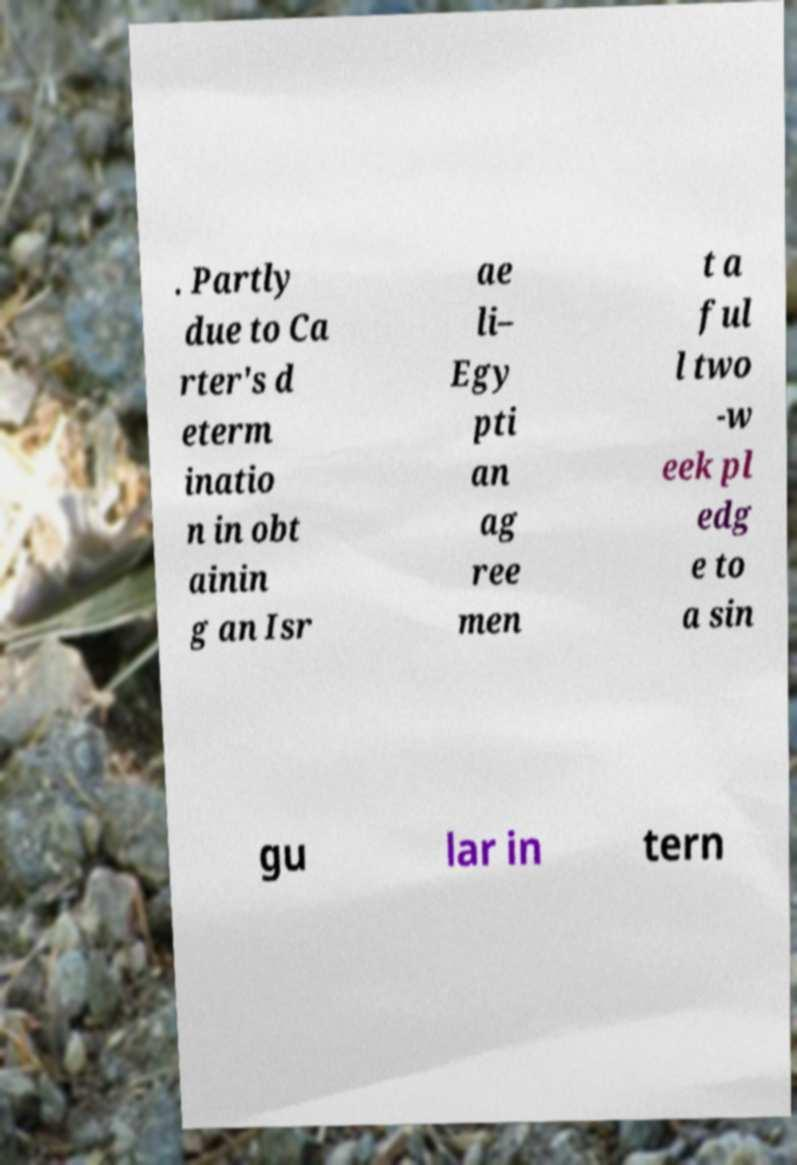Can you accurately transcribe the text from the provided image for me? . Partly due to Ca rter's d eterm inatio n in obt ainin g an Isr ae li– Egy pti an ag ree men t a ful l two -w eek pl edg e to a sin gu lar in tern 